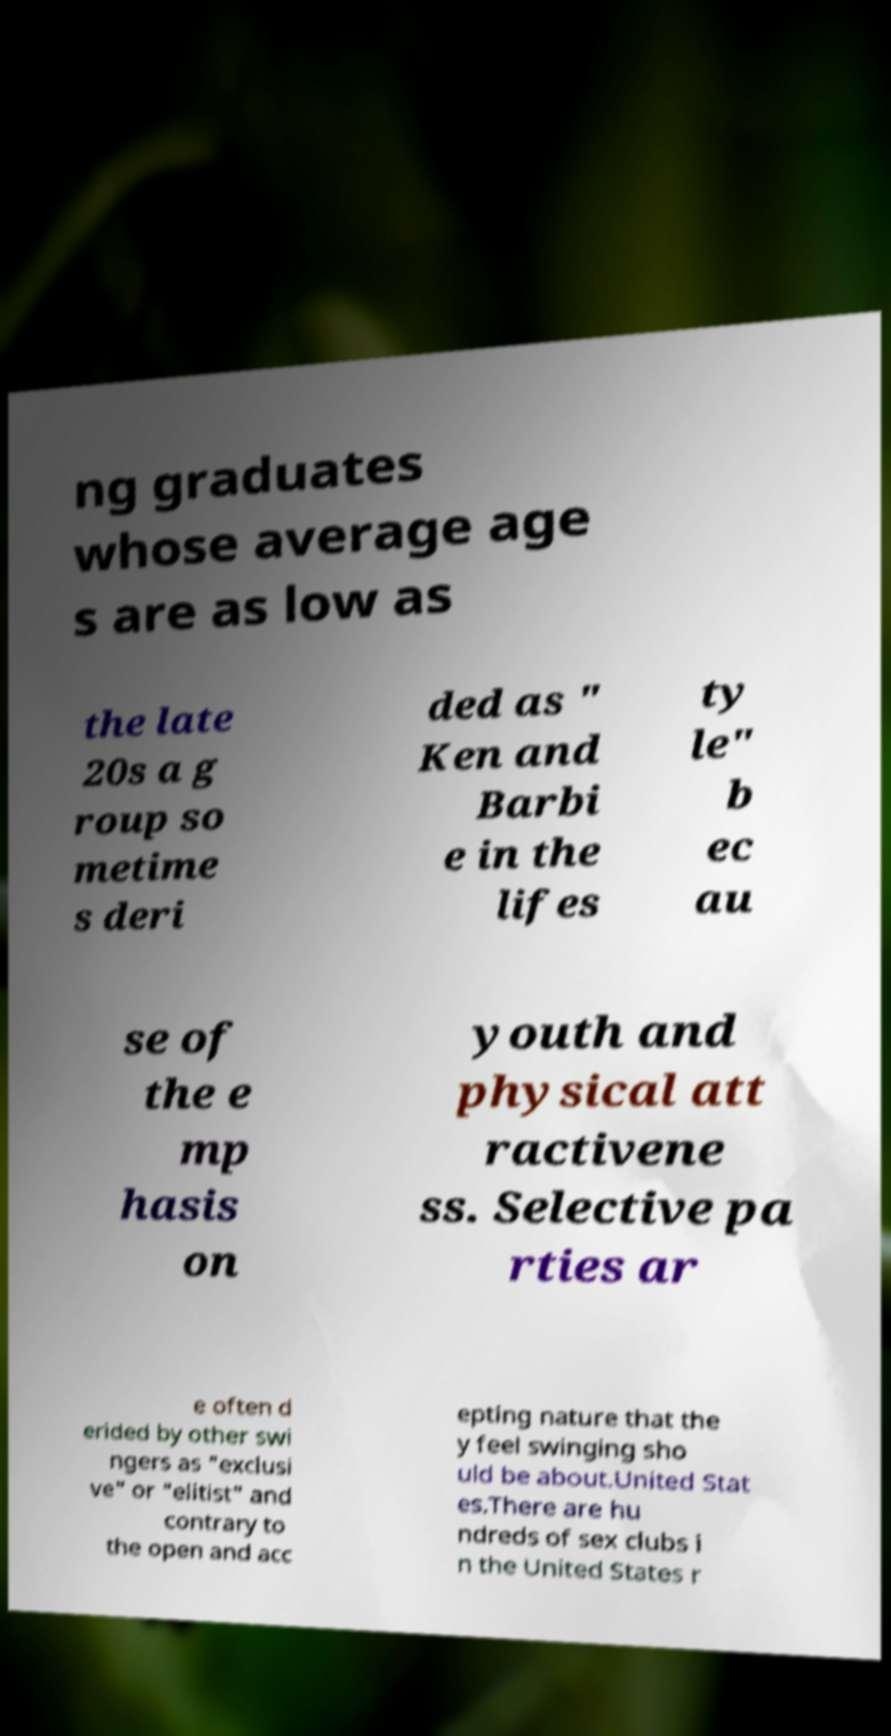Could you assist in decoding the text presented in this image and type it out clearly? ng graduates whose average age s are as low as the late 20s a g roup so metime s deri ded as " Ken and Barbi e in the lifes ty le" b ec au se of the e mp hasis on youth and physical att ractivene ss. Selective pa rties ar e often d erided by other swi ngers as "exclusi ve" or "elitist" and contrary to the open and acc epting nature that the y feel swinging sho uld be about.United Stat es.There are hu ndreds of sex clubs i n the United States r 